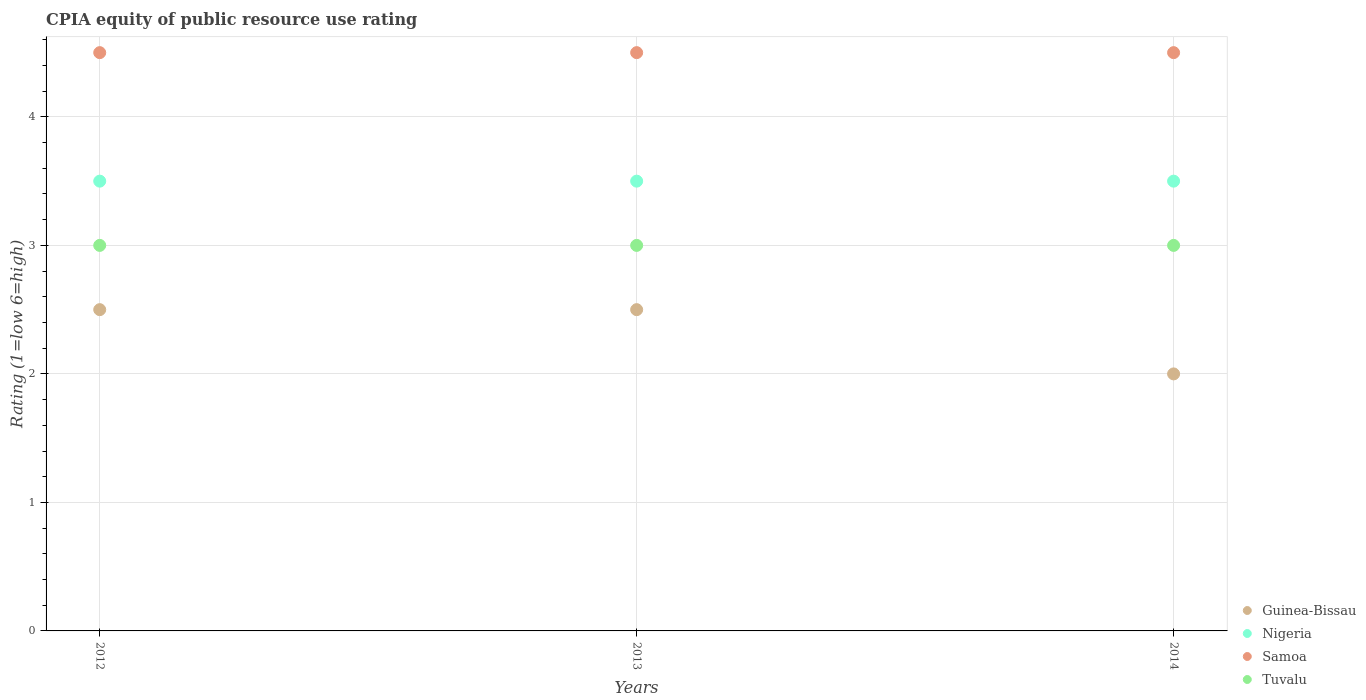In which year was the CPIA rating in Samoa minimum?
Your answer should be compact. 2012. In the year 2012, what is the difference between the CPIA rating in Samoa and CPIA rating in Tuvalu?
Keep it short and to the point. 1.5. What is the ratio of the CPIA rating in Nigeria in 2012 to that in 2013?
Provide a succinct answer. 1. What is the difference between the highest and the second highest CPIA rating in Samoa?
Ensure brevity in your answer.  0. What is the difference between the highest and the lowest CPIA rating in Samoa?
Ensure brevity in your answer.  0. Is it the case that in every year, the sum of the CPIA rating in Tuvalu and CPIA rating in Samoa  is greater than the sum of CPIA rating in Guinea-Bissau and CPIA rating in Nigeria?
Provide a short and direct response. Yes. Is it the case that in every year, the sum of the CPIA rating in Tuvalu and CPIA rating in Samoa  is greater than the CPIA rating in Guinea-Bissau?
Provide a succinct answer. Yes. Does the CPIA rating in Samoa monotonically increase over the years?
Offer a terse response. No. Is the CPIA rating in Samoa strictly greater than the CPIA rating in Nigeria over the years?
Your answer should be compact. Yes. How many dotlines are there?
Provide a short and direct response. 4. What is the difference between two consecutive major ticks on the Y-axis?
Your response must be concise. 1. Does the graph contain any zero values?
Keep it short and to the point. No. Does the graph contain grids?
Your response must be concise. Yes. Where does the legend appear in the graph?
Your answer should be compact. Bottom right. How many legend labels are there?
Offer a very short reply. 4. How are the legend labels stacked?
Make the answer very short. Vertical. What is the title of the graph?
Give a very brief answer. CPIA equity of public resource use rating. What is the label or title of the X-axis?
Make the answer very short. Years. What is the label or title of the Y-axis?
Keep it short and to the point. Rating (1=low 6=high). What is the Rating (1=low 6=high) of Guinea-Bissau in 2012?
Ensure brevity in your answer.  2.5. What is the Rating (1=low 6=high) in Samoa in 2012?
Keep it short and to the point. 4.5. What is the Rating (1=low 6=high) in Tuvalu in 2013?
Offer a terse response. 3. Across all years, what is the maximum Rating (1=low 6=high) in Guinea-Bissau?
Your answer should be very brief. 2.5. Across all years, what is the maximum Rating (1=low 6=high) of Nigeria?
Offer a very short reply. 3.5. Across all years, what is the minimum Rating (1=low 6=high) in Guinea-Bissau?
Keep it short and to the point. 2. Across all years, what is the minimum Rating (1=low 6=high) of Nigeria?
Keep it short and to the point. 3.5. What is the total Rating (1=low 6=high) of Nigeria in the graph?
Your response must be concise. 10.5. What is the total Rating (1=low 6=high) in Samoa in the graph?
Keep it short and to the point. 13.5. What is the total Rating (1=low 6=high) in Tuvalu in the graph?
Provide a succinct answer. 9. What is the difference between the Rating (1=low 6=high) of Samoa in 2012 and that in 2013?
Give a very brief answer. 0. What is the difference between the Rating (1=low 6=high) in Tuvalu in 2012 and that in 2013?
Your answer should be compact. 0. What is the difference between the Rating (1=low 6=high) in Guinea-Bissau in 2012 and that in 2014?
Provide a succinct answer. 0.5. What is the difference between the Rating (1=low 6=high) in Tuvalu in 2012 and that in 2014?
Give a very brief answer. 0. What is the difference between the Rating (1=low 6=high) in Guinea-Bissau in 2013 and that in 2014?
Offer a terse response. 0.5. What is the difference between the Rating (1=low 6=high) of Samoa in 2013 and that in 2014?
Give a very brief answer. 0. What is the difference between the Rating (1=low 6=high) of Guinea-Bissau in 2012 and the Rating (1=low 6=high) of Samoa in 2013?
Provide a short and direct response. -2. What is the difference between the Rating (1=low 6=high) in Nigeria in 2012 and the Rating (1=low 6=high) in Tuvalu in 2013?
Give a very brief answer. 0.5. What is the difference between the Rating (1=low 6=high) in Samoa in 2012 and the Rating (1=low 6=high) in Tuvalu in 2013?
Provide a short and direct response. 1.5. What is the difference between the Rating (1=low 6=high) of Guinea-Bissau in 2012 and the Rating (1=low 6=high) of Nigeria in 2014?
Give a very brief answer. -1. What is the difference between the Rating (1=low 6=high) of Nigeria in 2012 and the Rating (1=low 6=high) of Tuvalu in 2014?
Your answer should be compact. 0.5. What is the difference between the Rating (1=low 6=high) of Nigeria in 2013 and the Rating (1=low 6=high) of Tuvalu in 2014?
Your answer should be compact. 0.5. What is the difference between the Rating (1=low 6=high) of Samoa in 2013 and the Rating (1=low 6=high) of Tuvalu in 2014?
Keep it short and to the point. 1.5. What is the average Rating (1=low 6=high) of Guinea-Bissau per year?
Keep it short and to the point. 2.33. What is the average Rating (1=low 6=high) in Nigeria per year?
Ensure brevity in your answer.  3.5. What is the average Rating (1=low 6=high) in Tuvalu per year?
Offer a very short reply. 3. In the year 2012, what is the difference between the Rating (1=low 6=high) of Guinea-Bissau and Rating (1=low 6=high) of Nigeria?
Make the answer very short. -1. In the year 2012, what is the difference between the Rating (1=low 6=high) in Nigeria and Rating (1=low 6=high) in Tuvalu?
Keep it short and to the point. 0.5. In the year 2012, what is the difference between the Rating (1=low 6=high) in Samoa and Rating (1=low 6=high) in Tuvalu?
Your response must be concise. 1.5. In the year 2013, what is the difference between the Rating (1=low 6=high) of Guinea-Bissau and Rating (1=low 6=high) of Nigeria?
Give a very brief answer. -1. In the year 2013, what is the difference between the Rating (1=low 6=high) in Nigeria and Rating (1=low 6=high) in Samoa?
Provide a succinct answer. -1. In the year 2014, what is the difference between the Rating (1=low 6=high) in Guinea-Bissau and Rating (1=low 6=high) in Nigeria?
Offer a very short reply. -1.5. In the year 2014, what is the difference between the Rating (1=low 6=high) of Guinea-Bissau and Rating (1=low 6=high) of Samoa?
Make the answer very short. -2.5. In the year 2014, what is the difference between the Rating (1=low 6=high) in Guinea-Bissau and Rating (1=low 6=high) in Tuvalu?
Provide a succinct answer. -1. In the year 2014, what is the difference between the Rating (1=low 6=high) in Samoa and Rating (1=low 6=high) in Tuvalu?
Keep it short and to the point. 1.5. What is the ratio of the Rating (1=low 6=high) of Guinea-Bissau in 2012 to that in 2013?
Provide a short and direct response. 1. What is the ratio of the Rating (1=low 6=high) of Samoa in 2012 to that in 2013?
Provide a short and direct response. 1. What is the ratio of the Rating (1=low 6=high) of Tuvalu in 2013 to that in 2014?
Keep it short and to the point. 1. What is the difference between the highest and the second highest Rating (1=low 6=high) in Nigeria?
Provide a short and direct response. 0. What is the difference between the highest and the lowest Rating (1=low 6=high) of Nigeria?
Your answer should be very brief. 0. 